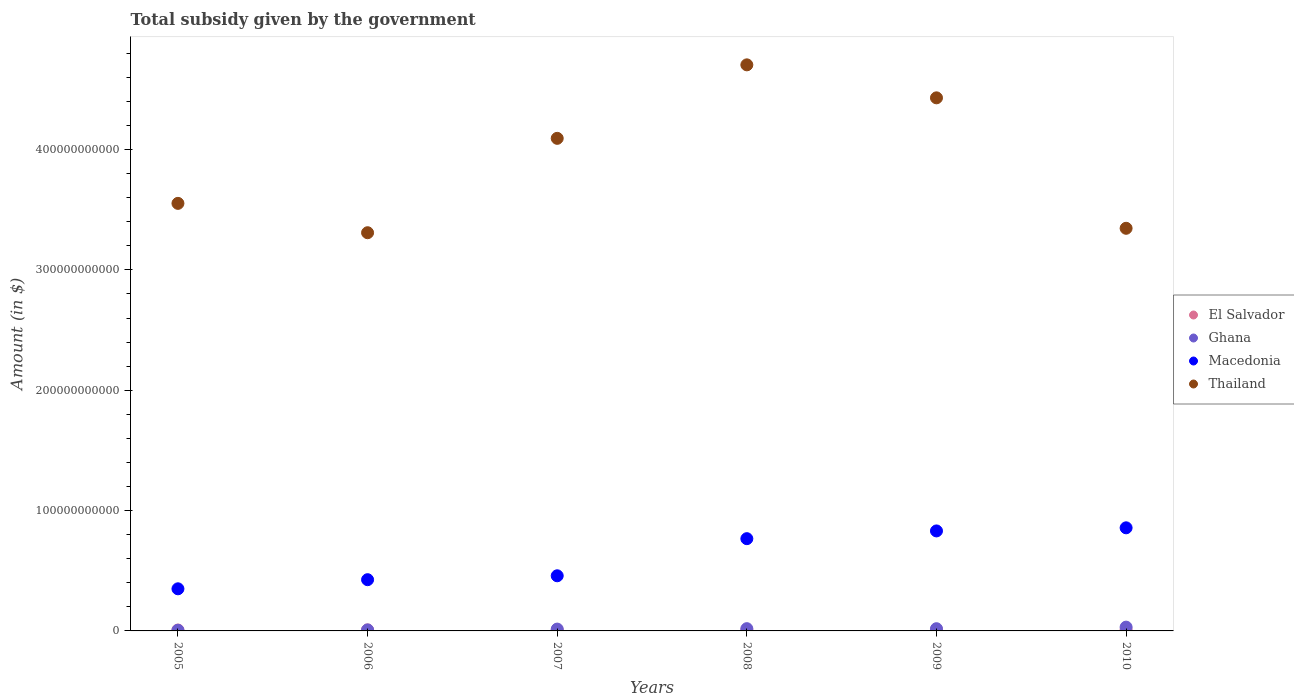Is the number of dotlines equal to the number of legend labels?
Your response must be concise. Yes. What is the total revenue collected by the government in Macedonia in 2007?
Your response must be concise. 4.58e+1. Across all years, what is the maximum total revenue collected by the government in Thailand?
Your response must be concise. 4.70e+11. Across all years, what is the minimum total revenue collected by the government in Thailand?
Ensure brevity in your answer.  3.31e+11. In which year was the total revenue collected by the government in Macedonia maximum?
Provide a succinct answer. 2010. In which year was the total revenue collected by the government in Macedonia minimum?
Make the answer very short. 2005. What is the total total revenue collected by the government in Thailand in the graph?
Make the answer very short. 2.34e+12. What is the difference between the total revenue collected by the government in Thailand in 2009 and that in 2010?
Your answer should be very brief. 1.08e+11. What is the difference between the total revenue collected by the government in El Salvador in 2009 and the total revenue collected by the government in Macedonia in 2007?
Keep it short and to the point. -4.49e+1. What is the average total revenue collected by the government in Ghana per year?
Provide a short and direct response. 1.63e+09. In the year 2006, what is the difference between the total revenue collected by the government in Thailand and total revenue collected by the government in El Salvador?
Keep it short and to the point. 3.30e+11. What is the ratio of the total revenue collected by the government in Macedonia in 2005 to that in 2009?
Ensure brevity in your answer.  0.42. Is the total revenue collected by the government in El Salvador in 2008 less than that in 2009?
Keep it short and to the point. Yes. Is the difference between the total revenue collected by the government in Thailand in 2008 and 2009 greater than the difference between the total revenue collected by the government in El Salvador in 2008 and 2009?
Provide a short and direct response. Yes. What is the difference between the highest and the second highest total revenue collected by the government in Macedonia?
Your answer should be compact. 2.58e+09. What is the difference between the highest and the lowest total revenue collected by the government in El Salvador?
Ensure brevity in your answer.  2.70e+08. In how many years, is the total revenue collected by the government in Thailand greater than the average total revenue collected by the government in Thailand taken over all years?
Your answer should be very brief. 3. Is the sum of the total revenue collected by the government in Ghana in 2005 and 2007 greater than the maximum total revenue collected by the government in Thailand across all years?
Provide a short and direct response. No. Is it the case that in every year, the sum of the total revenue collected by the government in Macedonia and total revenue collected by the government in Ghana  is greater than the sum of total revenue collected by the government in El Salvador and total revenue collected by the government in Thailand?
Your response must be concise. Yes. Is it the case that in every year, the sum of the total revenue collected by the government in Ghana and total revenue collected by the government in Thailand  is greater than the total revenue collected by the government in El Salvador?
Ensure brevity in your answer.  Yes. Does the total revenue collected by the government in Ghana monotonically increase over the years?
Provide a succinct answer. No. Is the total revenue collected by the government in El Salvador strictly greater than the total revenue collected by the government in Macedonia over the years?
Give a very brief answer. No. Is the total revenue collected by the government in Ghana strictly less than the total revenue collected by the government in El Salvador over the years?
Give a very brief answer. No. How many years are there in the graph?
Keep it short and to the point. 6. What is the difference between two consecutive major ticks on the Y-axis?
Offer a terse response. 1.00e+11. Are the values on the major ticks of Y-axis written in scientific E-notation?
Your answer should be compact. No. Does the graph contain grids?
Provide a succinct answer. No. Where does the legend appear in the graph?
Give a very brief answer. Center right. How are the legend labels stacked?
Ensure brevity in your answer.  Vertical. What is the title of the graph?
Your answer should be compact. Total subsidy given by the government. Does "Liechtenstein" appear as one of the legend labels in the graph?
Make the answer very short. No. What is the label or title of the Y-axis?
Offer a very short reply. Amount (in $). What is the Amount (in $) of El Salvador in 2005?
Keep it short and to the point. 7.40e+08. What is the Amount (in $) in Ghana in 2005?
Ensure brevity in your answer.  5.64e+08. What is the Amount (in $) in Macedonia in 2005?
Offer a very short reply. 3.50e+1. What is the Amount (in $) of Thailand in 2005?
Offer a terse response. 3.55e+11. What is the Amount (in $) in El Salvador in 2006?
Your answer should be compact. 8.40e+08. What is the Amount (in $) of Ghana in 2006?
Your answer should be compact. 8.37e+08. What is the Amount (in $) of Macedonia in 2006?
Make the answer very short. 4.26e+1. What is the Amount (in $) of Thailand in 2006?
Make the answer very short. 3.31e+11. What is the Amount (in $) of El Salvador in 2007?
Your answer should be compact. 7.31e+08. What is the Amount (in $) in Ghana in 2007?
Make the answer very short. 1.53e+09. What is the Amount (in $) of Macedonia in 2007?
Offer a very short reply. 4.58e+1. What is the Amount (in $) of Thailand in 2007?
Give a very brief answer. 4.09e+11. What is the Amount (in $) in El Salvador in 2008?
Offer a terse response. 8.66e+08. What is the Amount (in $) of Ghana in 2008?
Offer a very short reply. 1.87e+09. What is the Amount (in $) of Macedonia in 2008?
Your answer should be compact. 7.67e+1. What is the Amount (in $) of Thailand in 2008?
Your answer should be very brief. 4.70e+11. What is the Amount (in $) of El Salvador in 2009?
Give a very brief answer. 9.55e+08. What is the Amount (in $) of Ghana in 2009?
Provide a succinct answer. 1.84e+09. What is the Amount (in $) in Macedonia in 2009?
Ensure brevity in your answer.  8.31e+1. What is the Amount (in $) of Thailand in 2009?
Provide a short and direct response. 4.43e+11. What is the Amount (in $) in El Salvador in 2010?
Your response must be concise. 1.00e+09. What is the Amount (in $) of Ghana in 2010?
Keep it short and to the point. 3.15e+09. What is the Amount (in $) of Macedonia in 2010?
Ensure brevity in your answer.  8.57e+1. What is the Amount (in $) of Thailand in 2010?
Ensure brevity in your answer.  3.35e+11. Across all years, what is the maximum Amount (in $) of El Salvador?
Give a very brief answer. 1.00e+09. Across all years, what is the maximum Amount (in $) in Ghana?
Provide a short and direct response. 3.15e+09. Across all years, what is the maximum Amount (in $) in Macedonia?
Keep it short and to the point. 8.57e+1. Across all years, what is the maximum Amount (in $) in Thailand?
Give a very brief answer. 4.70e+11. Across all years, what is the minimum Amount (in $) in El Salvador?
Keep it short and to the point. 7.31e+08. Across all years, what is the minimum Amount (in $) in Ghana?
Provide a short and direct response. 5.64e+08. Across all years, what is the minimum Amount (in $) of Macedonia?
Your response must be concise. 3.50e+1. Across all years, what is the minimum Amount (in $) of Thailand?
Keep it short and to the point. 3.31e+11. What is the total Amount (in $) of El Salvador in the graph?
Provide a short and direct response. 5.13e+09. What is the total Amount (in $) in Ghana in the graph?
Your answer should be compact. 9.80e+09. What is the total Amount (in $) of Macedonia in the graph?
Offer a terse response. 3.69e+11. What is the total Amount (in $) in Thailand in the graph?
Give a very brief answer. 2.34e+12. What is the difference between the Amount (in $) of El Salvador in 2005 and that in 2006?
Your response must be concise. -9.95e+07. What is the difference between the Amount (in $) of Ghana in 2005 and that in 2006?
Ensure brevity in your answer.  -2.73e+08. What is the difference between the Amount (in $) in Macedonia in 2005 and that in 2006?
Provide a succinct answer. -7.58e+09. What is the difference between the Amount (in $) of Thailand in 2005 and that in 2006?
Your response must be concise. 2.44e+1. What is the difference between the Amount (in $) of El Salvador in 2005 and that in 2007?
Ensure brevity in your answer.  8.80e+06. What is the difference between the Amount (in $) of Ghana in 2005 and that in 2007?
Offer a terse response. -9.65e+08. What is the difference between the Amount (in $) in Macedonia in 2005 and that in 2007?
Your answer should be compact. -1.08e+1. What is the difference between the Amount (in $) of Thailand in 2005 and that in 2007?
Provide a short and direct response. -5.40e+1. What is the difference between the Amount (in $) of El Salvador in 2005 and that in 2008?
Make the answer very short. -1.26e+08. What is the difference between the Amount (in $) of Ghana in 2005 and that in 2008?
Provide a succinct answer. -1.31e+09. What is the difference between the Amount (in $) in Macedonia in 2005 and that in 2008?
Provide a succinct answer. -4.17e+1. What is the difference between the Amount (in $) of Thailand in 2005 and that in 2008?
Keep it short and to the point. -1.15e+11. What is the difference between the Amount (in $) in El Salvador in 2005 and that in 2009?
Offer a very short reply. -2.15e+08. What is the difference between the Amount (in $) of Ghana in 2005 and that in 2009?
Provide a short and direct response. -1.28e+09. What is the difference between the Amount (in $) of Macedonia in 2005 and that in 2009?
Offer a terse response. -4.81e+1. What is the difference between the Amount (in $) in Thailand in 2005 and that in 2009?
Your answer should be very brief. -8.77e+1. What is the difference between the Amount (in $) of El Salvador in 2005 and that in 2010?
Ensure brevity in your answer.  -2.61e+08. What is the difference between the Amount (in $) of Ghana in 2005 and that in 2010?
Your answer should be compact. -2.59e+09. What is the difference between the Amount (in $) of Macedonia in 2005 and that in 2010?
Make the answer very short. -5.07e+1. What is the difference between the Amount (in $) of Thailand in 2005 and that in 2010?
Offer a terse response. 2.07e+1. What is the difference between the Amount (in $) of El Salvador in 2006 and that in 2007?
Your response must be concise. 1.08e+08. What is the difference between the Amount (in $) of Ghana in 2006 and that in 2007?
Make the answer very short. -6.92e+08. What is the difference between the Amount (in $) of Macedonia in 2006 and that in 2007?
Provide a succinct answer. -3.25e+09. What is the difference between the Amount (in $) of Thailand in 2006 and that in 2007?
Keep it short and to the point. -7.84e+1. What is the difference between the Amount (in $) of El Salvador in 2006 and that in 2008?
Keep it short and to the point. -2.67e+07. What is the difference between the Amount (in $) in Ghana in 2006 and that in 2008?
Your answer should be compact. -1.03e+09. What is the difference between the Amount (in $) in Macedonia in 2006 and that in 2008?
Your answer should be very brief. -3.41e+1. What is the difference between the Amount (in $) of Thailand in 2006 and that in 2008?
Keep it short and to the point. -1.40e+11. What is the difference between the Amount (in $) in El Salvador in 2006 and that in 2009?
Offer a very short reply. -1.16e+08. What is the difference between the Amount (in $) in Ghana in 2006 and that in 2009?
Provide a short and direct response. -1.01e+09. What is the difference between the Amount (in $) in Macedonia in 2006 and that in 2009?
Your answer should be very brief. -4.05e+1. What is the difference between the Amount (in $) in Thailand in 2006 and that in 2009?
Your response must be concise. -1.12e+11. What is the difference between the Amount (in $) of El Salvador in 2006 and that in 2010?
Your answer should be very brief. -1.61e+08. What is the difference between the Amount (in $) of Ghana in 2006 and that in 2010?
Your answer should be compact. -2.32e+09. What is the difference between the Amount (in $) of Macedonia in 2006 and that in 2010?
Provide a short and direct response. -4.31e+1. What is the difference between the Amount (in $) of Thailand in 2006 and that in 2010?
Provide a short and direct response. -3.68e+09. What is the difference between the Amount (in $) in El Salvador in 2007 and that in 2008?
Make the answer very short. -1.35e+08. What is the difference between the Amount (in $) of Ghana in 2007 and that in 2008?
Provide a succinct answer. -3.43e+08. What is the difference between the Amount (in $) of Macedonia in 2007 and that in 2008?
Provide a short and direct response. -3.08e+1. What is the difference between the Amount (in $) of Thailand in 2007 and that in 2008?
Your answer should be compact. -6.11e+1. What is the difference between the Amount (in $) in El Salvador in 2007 and that in 2009?
Make the answer very short. -2.24e+08. What is the difference between the Amount (in $) in Ghana in 2007 and that in 2009?
Provide a short and direct response. -3.14e+08. What is the difference between the Amount (in $) in Macedonia in 2007 and that in 2009?
Give a very brief answer. -3.73e+1. What is the difference between the Amount (in $) in Thailand in 2007 and that in 2009?
Provide a short and direct response. -3.37e+1. What is the difference between the Amount (in $) of El Salvador in 2007 and that in 2010?
Provide a succinct answer. -2.70e+08. What is the difference between the Amount (in $) in Ghana in 2007 and that in 2010?
Provide a succinct answer. -1.63e+09. What is the difference between the Amount (in $) of Macedonia in 2007 and that in 2010?
Provide a short and direct response. -3.99e+1. What is the difference between the Amount (in $) of Thailand in 2007 and that in 2010?
Ensure brevity in your answer.  7.47e+1. What is the difference between the Amount (in $) of El Salvador in 2008 and that in 2009?
Your response must be concise. -8.88e+07. What is the difference between the Amount (in $) in Ghana in 2008 and that in 2009?
Provide a short and direct response. 2.92e+07. What is the difference between the Amount (in $) in Macedonia in 2008 and that in 2009?
Give a very brief answer. -6.44e+09. What is the difference between the Amount (in $) in Thailand in 2008 and that in 2009?
Give a very brief answer. 2.74e+1. What is the difference between the Amount (in $) of El Salvador in 2008 and that in 2010?
Ensure brevity in your answer.  -1.34e+08. What is the difference between the Amount (in $) of Ghana in 2008 and that in 2010?
Provide a succinct answer. -1.28e+09. What is the difference between the Amount (in $) in Macedonia in 2008 and that in 2010?
Give a very brief answer. -9.02e+09. What is the difference between the Amount (in $) in Thailand in 2008 and that in 2010?
Give a very brief answer. 1.36e+11. What is the difference between the Amount (in $) of El Salvador in 2009 and that in 2010?
Provide a succinct answer. -4.57e+07. What is the difference between the Amount (in $) in Ghana in 2009 and that in 2010?
Your answer should be compact. -1.31e+09. What is the difference between the Amount (in $) in Macedonia in 2009 and that in 2010?
Offer a terse response. -2.58e+09. What is the difference between the Amount (in $) of Thailand in 2009 and that in 2010?
Your response must be concise. 1.08e+11. What is the difference between the Amount (in $) in El Salvador in 2005 and the Amount (in $) in Ghana in 2006?
Make the answer very short. -9.67e+07. What is the difference between the Amount (in $) in El Salvador in 2005 and the Amount (in $) in Macedonia in 2006?
Offer a very short reply. -4.18e+1. What is the difference between the Amount (in $) of El Salvador in 2005 and the Amount (in $) of Thailand in 2006?
Your answer should be compact. -3.30e+11. What is the difference between the Amount (in $) of Ghana in 2005 and the Amount (in $) of Macedonia in 2006?
Provide a short and direct response. -4.20e+1. What is the difference between the Amount (in $) of Ghana in 2005 and the Amount (in $) of Thailand in 2006?
Offer a terse response. -3.30e+11. What is the difference between the Amount (in $) in Macedonia in 2005 and the Amount (in $) in Thailand in 2006?
Your answer should be compact. -2.96e+11. What is the difference between the Amount (in $) of El Salvador in 2005 and the Amount (in $) of Ghana in 2007?
Your answer should be compact. -7.89e+08. What is the difference between the Amount (in $) in El Salvador in 2005 and the Amount (in $) in Macedonia in 2007?
Ensure brevity in your answer.  -4.51e+1. What is the difference between the Amount (in $) in El Salvador in 2005 and the Amount (in $) in Thailand in 2007?
Your answer should be very brief. -4.09e+11. What is the difference between the Amount (in $) of Ghana in 2005 and the Amount (in $) of Macedonia in 2007?
Your response must be concise. -4.53e+1. What is the difference between the Amount (in $) of Ghana in 2005 and the Amount (in $) of Thailand in 2007?
Make the answer very short. -4.09e+11. What is the difference between the Amount (in $) of Macedonia in 2005 and the Amount (in $) of Thailand in 2007?
Your response must be concise. -3.74e+11. What is the difference between the Amount (in $) in El Salvador in 2005 and the Amount (in $) in Ghana in 2008?
Give a very brief answer. -1.13e+09. What is the difference between the Amount (in $) of El Salvador in 2005 and the Amount (in $) of Macedonia in 2008?
Your answer should be very brief. -7.59e+1. What is the difference between the Amount (in $) in El Salvador in 2005 and the Amount (in $) in Thailand in 2008?
Your response must be concise. -4.70e+11. What is the difference between the Amount (in $) of Ghana in 2005 and the Amount (in $) of Macedonia in 2008?
Your answer should be very brief. -7.61e+1. What is the difference between the Amount (in $) in Ghana in 2005 and the Amount (in $) in Thailand in 2008?
Offer a very short reply. -4.70e+11. What is the difference between the Amount (in $) in Macedonia in 2005 and the Amount (in $) in Thailand in 2008?
Offer a terse response. -4.35e+11. What is the difference between the Amount (in $) of El Salvador in 2005 and the Amount (in $) of Ghana in 2009?
Give a very brief answer. -1.10e+09. What is the difference between the Amount (in $) in El Salvador in 2005 and the Amount (in $) in Macedonia in 2009?
Your answer should be compact. -8.24e+1. What is the difference between the Amount (in $) in El Salvador in 2005 and the Amount (in $) in Thailand in 2009?
Provide a succinct answer. -4.42e+11. What is the difference between the Amount (in $) of Ghana in 2005 and the Amount (in $) of Macedonia in 2009?
Your answer should be compact. -8.25e+1. What is the difference between the Amount (in $) of Ghana in 2005 and the Amount (in $) of Thailand in 2009?
Keep it short and to the point. -4.42e+11. What is the difference between the Amount (in $) of Macedonia in 2005 and the Amount (in $) of Thailand in 2009?
Your response must be concise. -4.08e+11. What is the difference between the Amount (in $) of El Salvador in 2005 and the Amount (in $) of Ghana in 2010?
Keep it short and to the point. -2.41e+09. What is the difference between the Amount (in $) of El Salvador in 2005 and the Amount (in $) of Macedonia in 2010?
Your response must be concise. -8.49e+1. What is the difference between the Amount (in $) of El Salvador in 2005 and the Amount (in $) of Thailand in 2010?
Your answer should be compact. -3.34e+11. What is the difference between the Amount (in $) in Ghana in 2005 and the Amount (in $) in Macedonia in 2010?
Give a very brief answer. -8.51e+1. What is the difference between the Amount (in $) of Ghana in 2005 and the Amount (in $) of Thailand in 2010?
Offer a terse response. -3.34e+11. What is the difference between the Amount (in $) in Macedonia in 2005 and the Amount (in $) in Thailand in 2010?
Provide a short and direct response. -3.00e+11. What is the difference between the Amount (in $) of El Salvador in 2006 and the Amount (in $) of Ghana in 2007?
Keep it short and to the point. -6.89e+08. What is the difference between the Amount (in $) of El Salvador in 2006 and the Amount (in $) of Macedonia in 2007?
Make the answer very short. -4.50e+1. What is the difference between the Amount (in $) in El Salvador in 2006 and the Amount (in $) in Thailand in 2007?
Ensure brevity in your answer.  -4.08e+11. What is the difference between the Amount (in $) in Ghana in 2006 and the Amount (in $) in Macedonia in 2007?
Offer a terse response. -4.50e+1. What is the difference between the Amount (in $) in Ghana in 2006 and the Amount (in $) in Thailand in 2007?
Keep it short and to the point. -4.08e+11. What is the difference between the Amount (in $) in Macedonia in 2006 and the Amount (in $) in Thailand in 2007?
Provide a succinct answer. -3.67e+11. What is the difference between the Amount (in $) in El Salvador in 2006 and the Amount (in $) in Ghana in 2008?
Your answer should be compact. -1.03e+09. What is the difference between the Amount (in $) of El Salvador in 2006 and the Amount (in $) of Macedonia in 2008?
Your response must be concise. -7.58e+1. What is the difference between the Amount (in $) of El Salvador in 2006 and the Amount (in $) of Thailand in 2008?
Offer a very short reply. -4.70e+11. What is the difference between the Amount (in $) in Ghana in 2006 and the Amount (in $) in Macedonia in 2008?
Give a very brief answer. -7.58e+1. What is the difference between the Amount (in $) in Ghana in 2006 and the Amount (in $) in Thailand in 2008?
Your answer should be very brief. -4.70e+11. What is the difference between the Amount (in $) of Macedonia in 2006 and the Amount (in $) of Thailand in 2008?
Keep it short and to the point. -4.28e+11. What is the difference between the Amount (in $) in El Salvador in 2006 and the Amount (in $) in Ghana in 2009?
Your answer should be compact. -1.00e+09. What is the difference between the Amount (in $) in El Salvador in 2006 and the Amount (in $) in Macedonia in 2009?
Your answer should be very brief. -8.23e+1. What is the difference between the Amount (in $) in El Salvador in 2006 and the Amount (in $) in Thailand in 2009?
Provide a succinct answer. -4.42e+11. What is the difference between the Amount (in $) of Ghana in 2006 and the Amount (in $) of Macedonia in 2009?
Offer a terse response. -8.23e+1. What is the difference between the Amount (in $) in Ghana in 2006 and the Amount (in $) in Thailand in 2009?
Ensure brevity in your answer.  -4.42e+11. What is the difference between the Amount (in $) in Macedonia in 2006 and the Amount (in $) in Thailand in 2009?
Keep it short and to the point. -4.00e+11. What is the difference between the Amount (in $) in El Salvador in 2006 and the Amount (in $) in Ghana in 2010?
Offer a terse response. -2.31e+09. What is the difference between the Amount (in $) in El Salvador in 2006 and the Amount (in $) in Macedonia in 2010?
Give a very brief answer. -8.48e+1. What is the difference between the Amount (in $) in El Salvador in 2006 and the Amount (in $) in Thailand in 2010?
Provide a succinct answer. -3.34e+11. What is the difference between the Amount (in $) in Ghana in 2006 and the Amount (in $) in Macedonia in 2010?
Your answer should be very brief. -8.48e+1. What is the difference between the Amount (in $) of Ghana in 2006 and the Amount (in $) of Thailand in 2010?
Provide a short and direct response. -3.34e+11. What is the difference between the Amount (in $) in Macedonia in 2006 and the Amount (in $) in Thailand in 2010?
Give a very brief answer. -2.92e+11. What is the difference between the Amount (in $) in El Salvador in 2007 and the Amount (in $) in Ghana in 2008?
Provide a succinct answer. -1.14e+09. What is the difference between the Amount (in $) of El Salvador in 2007 and the Amount (in $) of Macedonia in 2008?
Keep it short and to the point. -7.59e+1. What is the difference between the Amount (in $) in El Salvador in 2007 and the Amount (in $) in Thailand in 2008?
Make the answer very short. -4.70e+11. What is the difference between the Amount (in $) of Ghana in 2007 and the Amount (in $) of Macedonia in 2008?
Provide a short and direct response. -7.51e+1. What is the difference between the Amount (in $) in Ghana in 2007 and the Amount (in $) in Thailand in 2008?
Keep it short and to the point. -4.69e+11. What is the difference between the Amount (in $) in Macedonia in 2007 and the Amount (in $) in Thailand in 2008?
Offer a terse response. -4.25e+11. What is the difference between the Amount (in $) of El Salvador in 2007 and the Amount (in $) of Ghana in 2009?
Make the answer very short. -1.11e+09. What is the difference between the Amount (in $) of El Salvador in 2007 and the Amount (in $) of Macedonia in 2009?
Offer a terse response. -8.24e+1. What is the difference between the Amount (in $) in El Salvador in 2007 and the Amount (in $) in Thailand in 2009?
Keep it short and to the point. -4.42e+11. What is the difference between the Amount (in $) of Ghana in 2007 and the Amount (in $) of Macedonia in 2009?
Provide a succinct answer. -8.16e+1. What is the difference between the Amount (in $) in Ghana in 2007 and the Amount (in $) in Thailand in 2009?
Keep it short and to the point. -4.41e+11. What is the difference between the Amount (in $) of Macedonia in 2007 and the Amount (in $) of Thailand in 2009?
Your answer should be compact. -3.97e+11. What is the difference between the Amount (in $) in El Salvador in 2007 and the Amount (in $) in Ghana in 2010?
Your answer should be very brief. -2.42e+09. What is the difference between the Amount (in $) in El Salvador in 2007 and the Amount (in $) in Macedonia in 2010?
Give a very brief answer. -8.49e+1. What is the difference between the Amount (in $) of El Salvador in 2007 and the Amount (in $) of Thailand in 2010?
Ensure brevity in your answer.  -3.34e+11. What is the difference between the Amount (in $) in Ghana in 2007 and the Amount (in $) in Macedonia in 2010?
Provide a short and direct response. -8.42e+1. What is the difference between the Amount (in $) in Ghana in 2007 and the Amount (in $) in Thailand in 2010?
Give a very brief answer. -3.33e+11. What is the difference between the Amount (in $) in Macedonia in 2007 and the Amount (in $) in Thailand in 2010?
Ensure brevity in your answer.  -2.89e+11. What is the difference between the Amount (in $) in El Salvador in 2008 and the Amount (in $) in Ghana in 2009?
Offer a very short reply. -9.76e+08. What is the difference between the Amount (in $) of El Salvador in 2008 and the Amount (in $) of Macedonia in 2009?
Your answer should be very brief. -8.22e+1. What is the difference between the Amount (in $) in El Salvador in 2008 and the Amount (in $) in Thailand in 2009?
Your answer should be compact. -4.42e+11. What is the difference between the Amount (in $) in Ghana in 2008 and the Amount (in $) in Macedonia in 2009?
Your response must be concise. -8.12e+1. What is the difference between the Amount (in $) in Ghana in 2008 and the Amount (in $) in Thailand in 2009?
Offer a very short reply. -4.41e+11. What is the difference between the Amount (in $) in Macedonia in 2008 and the Amount (in $) in Thailand in 2009?
Your answer should be very brief. -3.66e+11. What is the difference between the Amount (in $) of El Salvador in 2008 and the Amount (in $) of Ghana in 2010?
Offer a very short reply. -2.29e+09. What is the difference between the Amount (in $) in El Salvador in 2008 and the Amount (in $) in Macedonia in 2010?
Your response must be concise. -8.48e+1. What is the difference between the Amount (in $) in El Salvador in 2008 and the Amount (in $) in Thailand in 2010?
Give a very brief answer. -3.34e+11. What is the difference between the Amount (in $) in Ghana in 2008 and the Amount (in $) in Macedonia in 2010?
Give a very brief answer. -8.38e+1. What is the difference between the Amount (in $) in Ghana in 2008 and the Amount (in $) in Thailand in 2010?
Your answer should be compact. -3.33e+11. What is the difference between the Amount (in $) in Macedonia in 2008 and the Amount (in $) in Thailand in 2010?
Your response must be concise. -2.58e+11. What is the difference between the Amount (in $) of El Salvador in 2009 and the Amount (in $) of Ghana in 2010?
Make the answer very short. -2.20e+09. What is the difference between the Amount (in $) of El Salvador in 2009 and the Amount (in $) of Macedonia in 2010?
Offer a very short reply. -8.47e+1. What is the difference between the Amount (in $) in El Salvador in 2009 and the Amount (in $) in Thailand in 2010?
Make the answer very short. -3.34e+11. What is the difference between the Amount (in $) in Ghana in 2009 and the Amount (in $) in Macedonia in 2010?
Your response must be concise. -8.38e+1. What is the difference between the Amount (in $) in Ghana in 2009 and the Amount (in $) in Thailand in 2010?
Your answer should be very brief. -3.33e+11. What is the difference between the Amount (in $) of Macedonia in 2009 and the Amount (in $) of Thailand in 2010?
Your answer should be very brief. -2.51e+11. What is the average Amount (in $) in El Salvador per year?
Your answer should be very brief. 8.55e+08. What is the average Amount (in $) of Ghana per year?
Your answer should be compact. 1.63e+09. What is the average Amount (in $) of Macedonia per year?
Your answer should be very brief. 6.15e+1. What is the average Amount (in $) in Thailand per year?
Provide a succinct answer. 3.91e+11. In the year 2005, what is the difference between the Amount (in $) in El Salvador and Amount (in $) in Ghana?
Offer a terse response. 1.76e+08. In the year 2005, what is the difference between the Amount (in $) of El Salvador and Amount (in $) of Macedonia?
Ensure brevity in your answer.  -3.43e+1. In the year 2005, what is the difference between the Amount (in $) of El Salvador and Amount (in $) of Thailand?
Keep it short and to the point. -3.55e+11. In the year 2005, what is the difference between the Amount (in $) in Ghana and Amount (in $) in Macedonia?
Make the answer very short. -3.44e+1. In the year 2005, what is the difference between the Amount (in $) in Ghana and Amount (in $) in Thailand?
Your answer should be compact. -3.55e+11. In the year 2005, what is the difference between the Amount (in $) in Macedonia and Amount (in $) in Thailand?
Offer a terse response. -3.20e+11. In the year 2006, what is the difference between the Amount (in $) in El Salvador and Amount (in $) in Ghana?
Make the answer very short. 2.84e+06. In the year 2006, what is the difference between the Amount (in $) of El Salvador and Amount (in $) of Macedonia?
Give a very brief answer. -4.17e+1. In the year 2006, what is the difference between the Amount (in $) in El Salvador and Amount (in $) in Thailand?
Make the answer very short. -3.30e+11. In the year 2006, what is the difference between the Amount (in $) of Ghana and Amount (in $) of Macedonia?
Give a very brief answer. -4.17e+1. In the year 2006, what is the difference between the Amount (in $) in Ghana and Amount (in $) in Thailand?
Give a very brief answer. -3.30e+11. In the year 2006, what is the difference between the Amount (in $) in Macedonia and Amount (in $) in Thailand?
Keep it short and to the point. -2.88e+11. In the year 2007, what is the difference between the Amount (in $) of El Salvador and Amount (in $) of Ghana?
Provide a short and direct response. -7.98e+08. In the year 2007, what is the difference between the Amount (in $) in El Salvador and Amount (in $) in Macedonia?
Make the answer very short. -4.51e+1. In the year 2007, what is the difference between the Amount (in $) in El Salvador and Amount (in $) in Thailand?
Offer a terse response. -4.09e+11. In the year 2007, what is the difference between the Amount (in $) in Ghana and Amount (in $) in Macedonia?
Offer a very short reply. -4.43e+1. In the year 2007, what is the difference between the Amount (in $) of Ghana and Amount (in $) of Thailand?
Provide a succinct answer. -4.08e+11. In the year 2007, what is the difference between the Amount (in $) of Macedonia and Amount (in $) of Thailand?
Give a very brief answer. -3.64e+11. In the year 2008, what is the difference between the Amount (in $) in El Salvador and Amount (in $) in Ghana?
Provide a short and direct response. -1.01e+09. In the year 2008, what is the difference between the Amount (in $) in El Salvador and Amount (in $) in Macedonia?
Ensure brevity in your answer.  -7.58e+1. In the year 2008, what is the difference between the Amount (in $) in El Salvador and Amount (in $) in Thailand?
Your answer should be very brief. -4.70e+11. In the year 2008, what is the difference between the Amount (in $) in Ghana and Amount (in $) in Macedonia?
Your answer should be compact. -7.48e+1. In the year 2008, what is the difference between the Amount (in $) in Ghana and Amount (in $) in Thailand?
Provide a short and direct response. -4.69e+11. In the year 2008, what is the difference between the Amount (in $) of Macedonia and Amount (in $) of Thailand?
Keep it short and to the point. -3.94e+11. In the year 2009, what is the difference between the Amount (in $) in El Salvador and Amount (in $) in Ghana?
Your answer should be compact. -8.87e+08. In the year 2009, what is the difference between the Amount (in $) of El Salvador and Amount (in $) of Macedonia?
Your answer should be compact. -8.21e+1. In the year 2009, what is the difference between the Amount (in $) in El Salvador and Amount (in $) in Thailand?
Offer a very short reply. -4.42e+11. In the year 2009, what is the difference between the Amount (in $) in Ghana and Amount (in $) in Macedonia?
Provide a short and direct response. -8.13e+1. In the year 2009, what is the difference between the Amount (in $) of Ghana and Amount (in $) of Thailand?
Make the answer very short. -4.41e+11. In the year 2009, what is the difference between the Amount (in $) of Macedonia and Amount (in $) of Thailand?
Keep it short and to the point. -3.60e+11. In the year 2010, what is the difference between the Amount (in $) in El Salvador and Amount (in $) in Ghana?
Offer a terse response. -2.15e+09. In the year 2010, what is the difference between the Amount (in $) in El Salvador and Amount (in $) in Macedonia?
Offer a terse response. -8.47e+1. In the year 2010, what is the difference between the Amount (in $) in El Salvador and Amount (in $) in Thailand?
Offer a terse response. -3.34e+11. In the year 2010, what is the difference between the Amount (in $) in Ghana and Amount (in $) in Macedonia?
Offer a very short reply. -8.25e+1. In the year 2010, what is the difference between the Amount (in $) of Ghana and Amount (in $) of Thailand?
Offer a very short reply. -3.31e+11. In the year 2010, what is the difference between the Amount (in $) of Macedonia and Amount (in $) of Thailand?
Your response must be concise. -2.49e+11. What is the ratio of the Amount (in $) of El Salvador in 2005 to that in 2006?
Ensure brevity in your answer.  0.88. What is the ratio of the Amount (in $) of Ghana in 2005 to that in 2006?
Your answer should be very brief. 0.67. What is the ratio of the Amount (in $) of Macedonia in 2005 to that in 2006?
Offer a very short reply. 0.82. What is the ratio of the Amount (in $) of Thailand in 2005 to that in 2006?
Offer a terse response. 1.07. What is the ratio of the Amount (in $) of Ghana in 2005 to that in 2007?
Your answer should be very brief. 0.37. What is the ratio of the Amount (in $) in Macedonia in 2005 to that in 2007?
Provide a succinct answer. 0.76. What is the ratio of the Amount (in $) of Thailand in 2005 to that in 2007?
Your answer should be compact. 0.87. What is the ratio of the Amount (in $) of El Salvador in 2005 to that in 2008?
Ensure brevity in your answer.  0.85. What is the ratio of the Amount (in $) of Ghana in 2005 to that in 2008?
Ensure brevity in your answer.  0.3. What is the ratio of the Amount (in $) of Macedonia in 2005 to that in 2008?
Your answer should be very brief. 0.46. What is the ratio of the Amount (in $) of Thailand in 2005 to that in 2008?
Offer a very short reply. 0.76. What is the ratio of the Amount (in $) of El Salvador in 2005 to that in 2009?
Keep it short and to the point. 0.77. What is the ratio of the Amount (in $) in Ghana in 2005 to that in 2009?
Offer a very short reply. 0.31. What is the ratio of the Amount (in $) of Macedonia in 2005 to that in 2009?
Your response must be concise. 0.42. What is the ratio of the Amount (in $) of Thailand in 2005 to that in 2009?
Give a very brief answer. 0.8. What is the ratio of the Amount (in $) in El Salvador in 2005 to that in 2010?
Your answer should be compact. 0.74. What is the ratio of the Amount (in $) of Ghana in 2005 to that in 2010?
Give a very brief answer. 0.18. What is the ratio of the Amount (in $) of Macedonia in 2005 to that in 2010?
Your response must be concise. 0.41. What is the ratio of the Amount (in $) of Thailand in 2005 to that in 2010?
Ensure brevity in your answer.  1.06. What is the ratio of the Amount (in $) of El Salvador in 2006 to that in 2007?
Provide a succinct answer. 1.15. What is the ratio of the Amount (in $) in Ghana in 2006 to that in 2007?
Offer a terse response. 0.55. What is the ratio of the Amount (in $) in Macedonia in 2006 to that in 2007?
Provide a short and direct response. 0.93. What is the ratio of the Amount (in $) of Thailand in 2006 to that in 2007?
Give a very brief answer. 0.81. What is the ratio of the Amount (in $) of El Salvador in 2006 to that in 2008?
Offer a terse response. 0.97. What is the ratio of the Amount (in $) in Ghana in 2006 to that in 2008?
Provide a short and direct response. 0.45. What is the ratio of the Amount (in $) of Macedonia in 2006 to that in 2008?
Make the answer very short. 0.56. What is the ratio of the Amount (in $) of Thailand in 2006 to that in 2008?
Your answer should be very brief. 0.7. What is the ratio of the Amount (in $) in El Salvador in 2006 to that in 2009?
Keep it short and to the point. 0.88. What is the ratio of the Amount (in $) of Ghana in 2006 to that in 2009?
Your response must be concise. 0.45. What is the ratio of the Amount (in $) in Macedonia in 2006 to that in 2009?
Offer a very short reply. 0.51. What is the ratio of the Amount (in $) in Thailand in 2006 to that in 2009?
Give a very brief answer. 0.75. What is the ratio of the Amount (in $) of El Salvador in 2006 to that in 2010?
Offer a very short reply. 0.84. What is the ratio of the Amount (in $) of Ghana in 2006 to that in 2010?
Ensure brevity in your answer.  0.27. What is the ratio of the Amount (in $) of Macedonia in 2006 to that in 2010?
Make the answer very short. 0.5. What is the ratio of the Amount (in $) in Thailand in 2006 to that in 2010?
Ensure brevity in your answer.  0.99. What is the ratio of the Amount (in $) of El Salvador in 2007 to that in 2008?
Offer a very short reply. 0.84. What is the ratio of the Amount (in $) in Ghana in 2007 to that in 2008?
Provide a short and direct response. 0.82. What is the ratio of the Amount (in $) of Macedonia in 2007 to that in 2008?
Offer a terse response. 0.6. What is the ratio of the Amount (in $) in Thailand in 2007 to that in 2008?
Your answer should be very brief. 0.87. What is the ratio of the Amount (in $) of El Salvador in 2007 to that in 2009?
Provide a short and direct response. 0.77. What is the ratio of the Amount (in $) of Ghana in 2007 to that in 2009?
Give a very brief answer. 0.83. What is the ratio of the Amount (in $) of Macedonia in 2007 to that in 2009?
Provide a succinct answer. 0.55. What is the ratio of the Amount (in $) in Thailand in 2007 to that in 2009?
Your response must be concise. 0.92. What is the ratio of the Amount (in $) of El Salvador in 2007 to that in 2010?
Offer a terse response. 0.73. What is the ratio of the Amount (in $) in Ghana in 2007 to that in 2010?
Your answer should be compact. 0.48. What is the ratio of the Amount (in $) of Macedonia in 2007 to that in 2010?
Offer a terse response. 0.53. What is the ratio of the Amount (in $) of Thailand in 2007 to that in 2010?
Your response must be concise. 1.22. What is the ratio of the Amount (in $) of El Salvador in 2008 to that in 2009?
Your answer should be compact. 0.91. What is the ratio of the Amount (in $) of Ghana in 2008 to that in 2009?
Provide a succinct answer. 1.02. What is the ratio of the Amount (in $) of Macedonia in 2008 to that in 2009?
Your answer should be compact. 0.92. What is the ratio of the Amount (in $) of Thailand in 2008 to that in 2009?
Keep it short and to the point. 1.06. What is the ratio of the Amount (in $) in El Salvador in 2008 to that in 2010?
Offer a terse response. 0.87. What is the ratio of the Amount (in $) of Ghana in 2008 to that in 2010?
Provide a short and direct response. 0.59. What is the ratio of the Amount (in $) in Macedonia in 2008 to that in 2010?
Ensure brevity in your answer.  0.89. What is the ratio of the Amount (in $) in Thailand in 2008 to that in 2010?
Your answer should be very brief. 1.41. What is the ratio of the Amount (in $) of El Salvador in 2009 to that in 2010?
Provide a short and direct response. 0.95. What is the ratio of the Amount (in $) in Ghana in 2009 to that in 2010?
Offer a very short reply. 0.58. What is the ratio of the Amount (in $) of Macedonia in 2009 to that in 2010?
Keep it short and to the point. 0.97. What is the ratio of the Amount (in $) in Thailand in 2009 to that in 2010?
Your response must be concise. 1.32. What is the difference between the highest and the second highest Amount (in $) of El Salvador?
Provide a short and direct response. 4.57e+07. What is the difference between the highest and the second highest Amount (in $) in Ghana?
Provide a short and direct response. 1.28e+09. What is the difference between the highest and the second highest Amount (in $) of Macedonia?
Your answer should be very brief. 2.58e+09. What is the difference between the highest and the second highest Amount (in $) of Thailand?
Provide a succinct answer. 2.74e+1. What is the difference between the highest and the lowest Amount (in $) in El Salvador?
Make the answer very short. 2.70e+08. What is the difference between the highest and the lowest Amount (in $) in Ghana?
Keep it short and to the point. 2.59e+09. What is the difference between the highest and the lowest Amount (in $) of Macedonia?
Offer a terse response. 5.07e+1. What is the difference between the highest and the lowest Amount (in $) in Thailand?
Provide a short and direct response. 1.40e+11. 